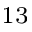<formula> <loc_0><loc_0><loc_500><loc_500>^ { 1 3 }</formula> 